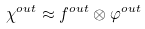<formula> <loc_0><loc_0><loc_500><loc_500>\chi ^ { o u t } \approx f ^ { o u t } \otimes \varphi ^ { o u t }</formula> 